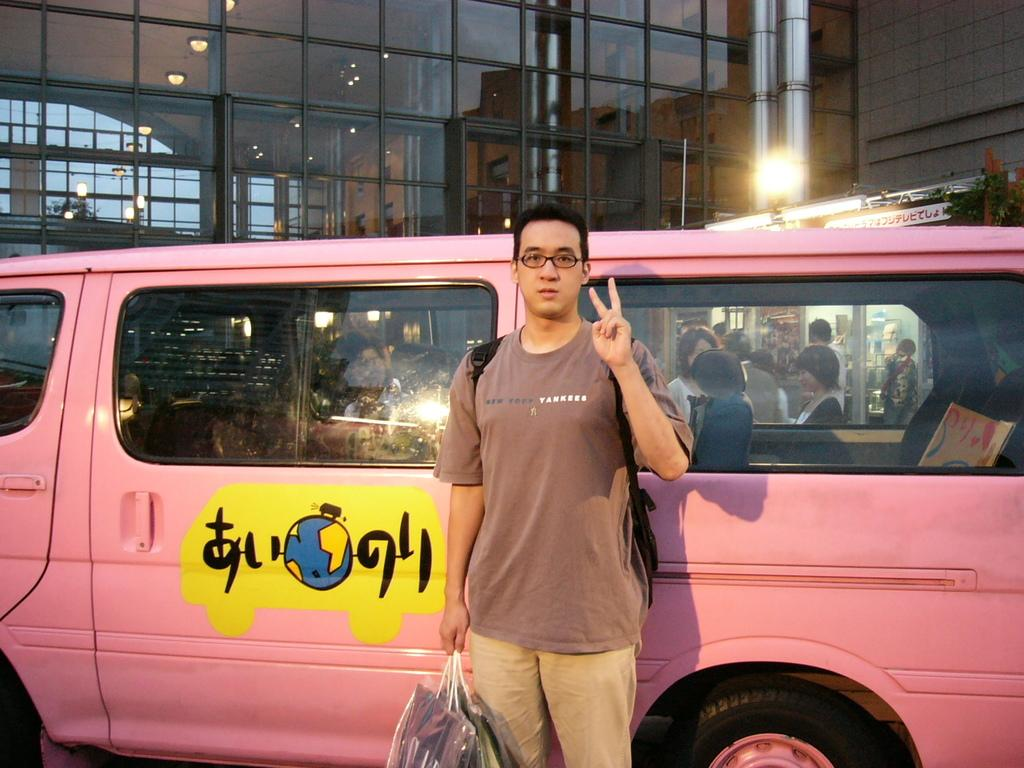Provide a one-sentence caption for the provided image. A man in a Yankees shirt stands in front of a pink vehicle. 